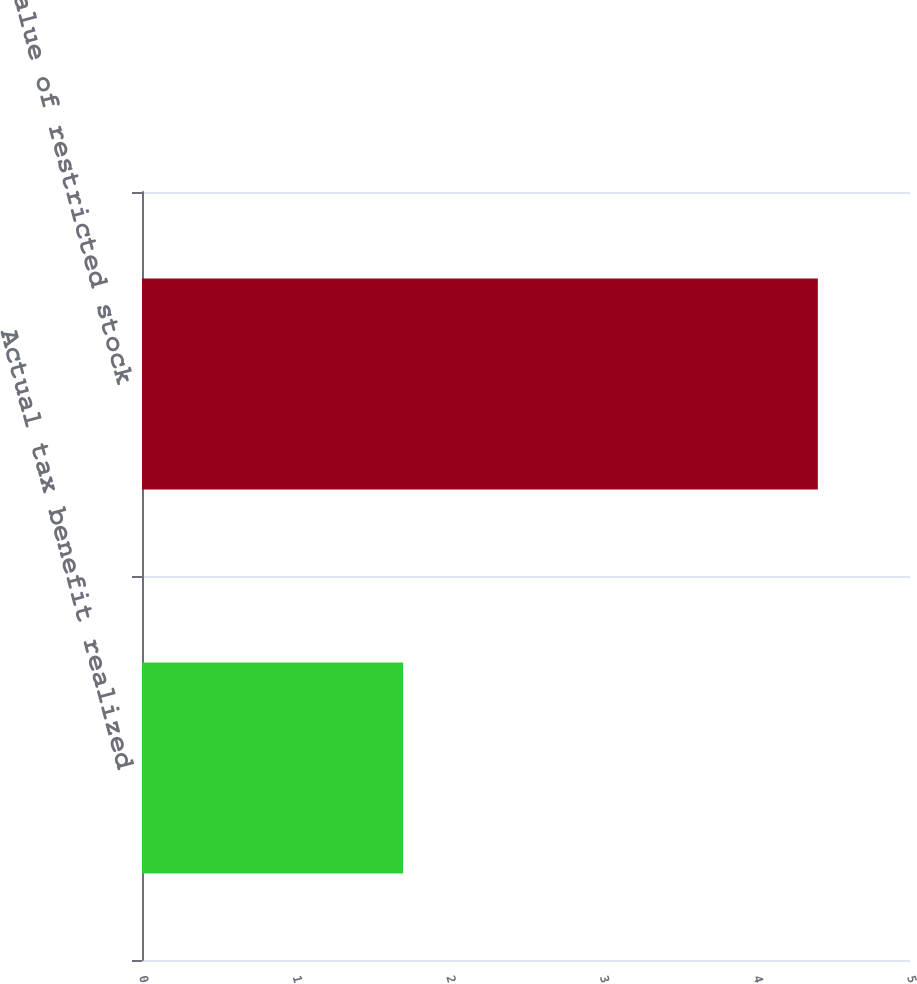<chart> <loc_0><loc_0><loc_500><loc_500><bar_chart><fcel>Actual tax benefit realized<fcel>Fair value of restricted stock<nl><fcel>1.7<fcel>4.4<nl></chart> 